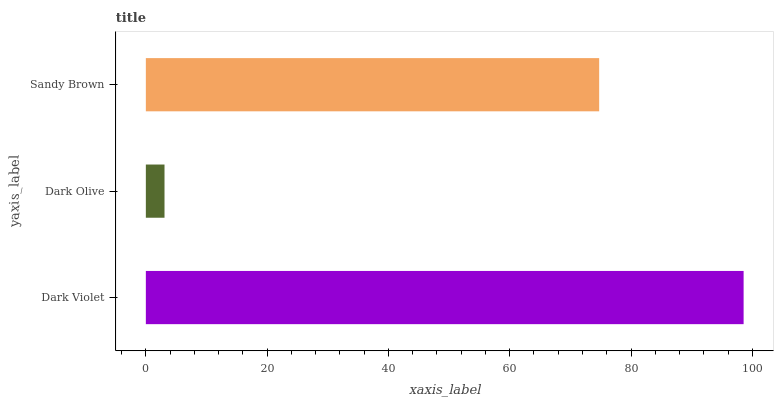Is Dark Olive the minimum?
Answer yes or no. Yes. Is Dark Violet the maximum?
Answer yes or no. Yes. Is Sandy Brown the minimum?
Answer yes or no. No. Is Sandy Brown the maximum?
Answer yes or no. No. Is Sandy Brown greater than Dark Olive?
Answer yes or no. Yes. Is Dark Olive less than Sandy Brown?
Answer yes or no. Yes. Is Dark Olive greater than Sandy Brown?
Answer yes or no. No. Is Sandy Brown less than Dark Olive?
Answer yes or no. No. Is Sandy Brown the high median?
Answer yes or no. Yes. Is Sandy Brown the low median?
Answer yes or no. Yes. Is Dark Violet the high median?
Answer yes or no. No. Is Dark Violet the low median?
Answer yes or no. No. 